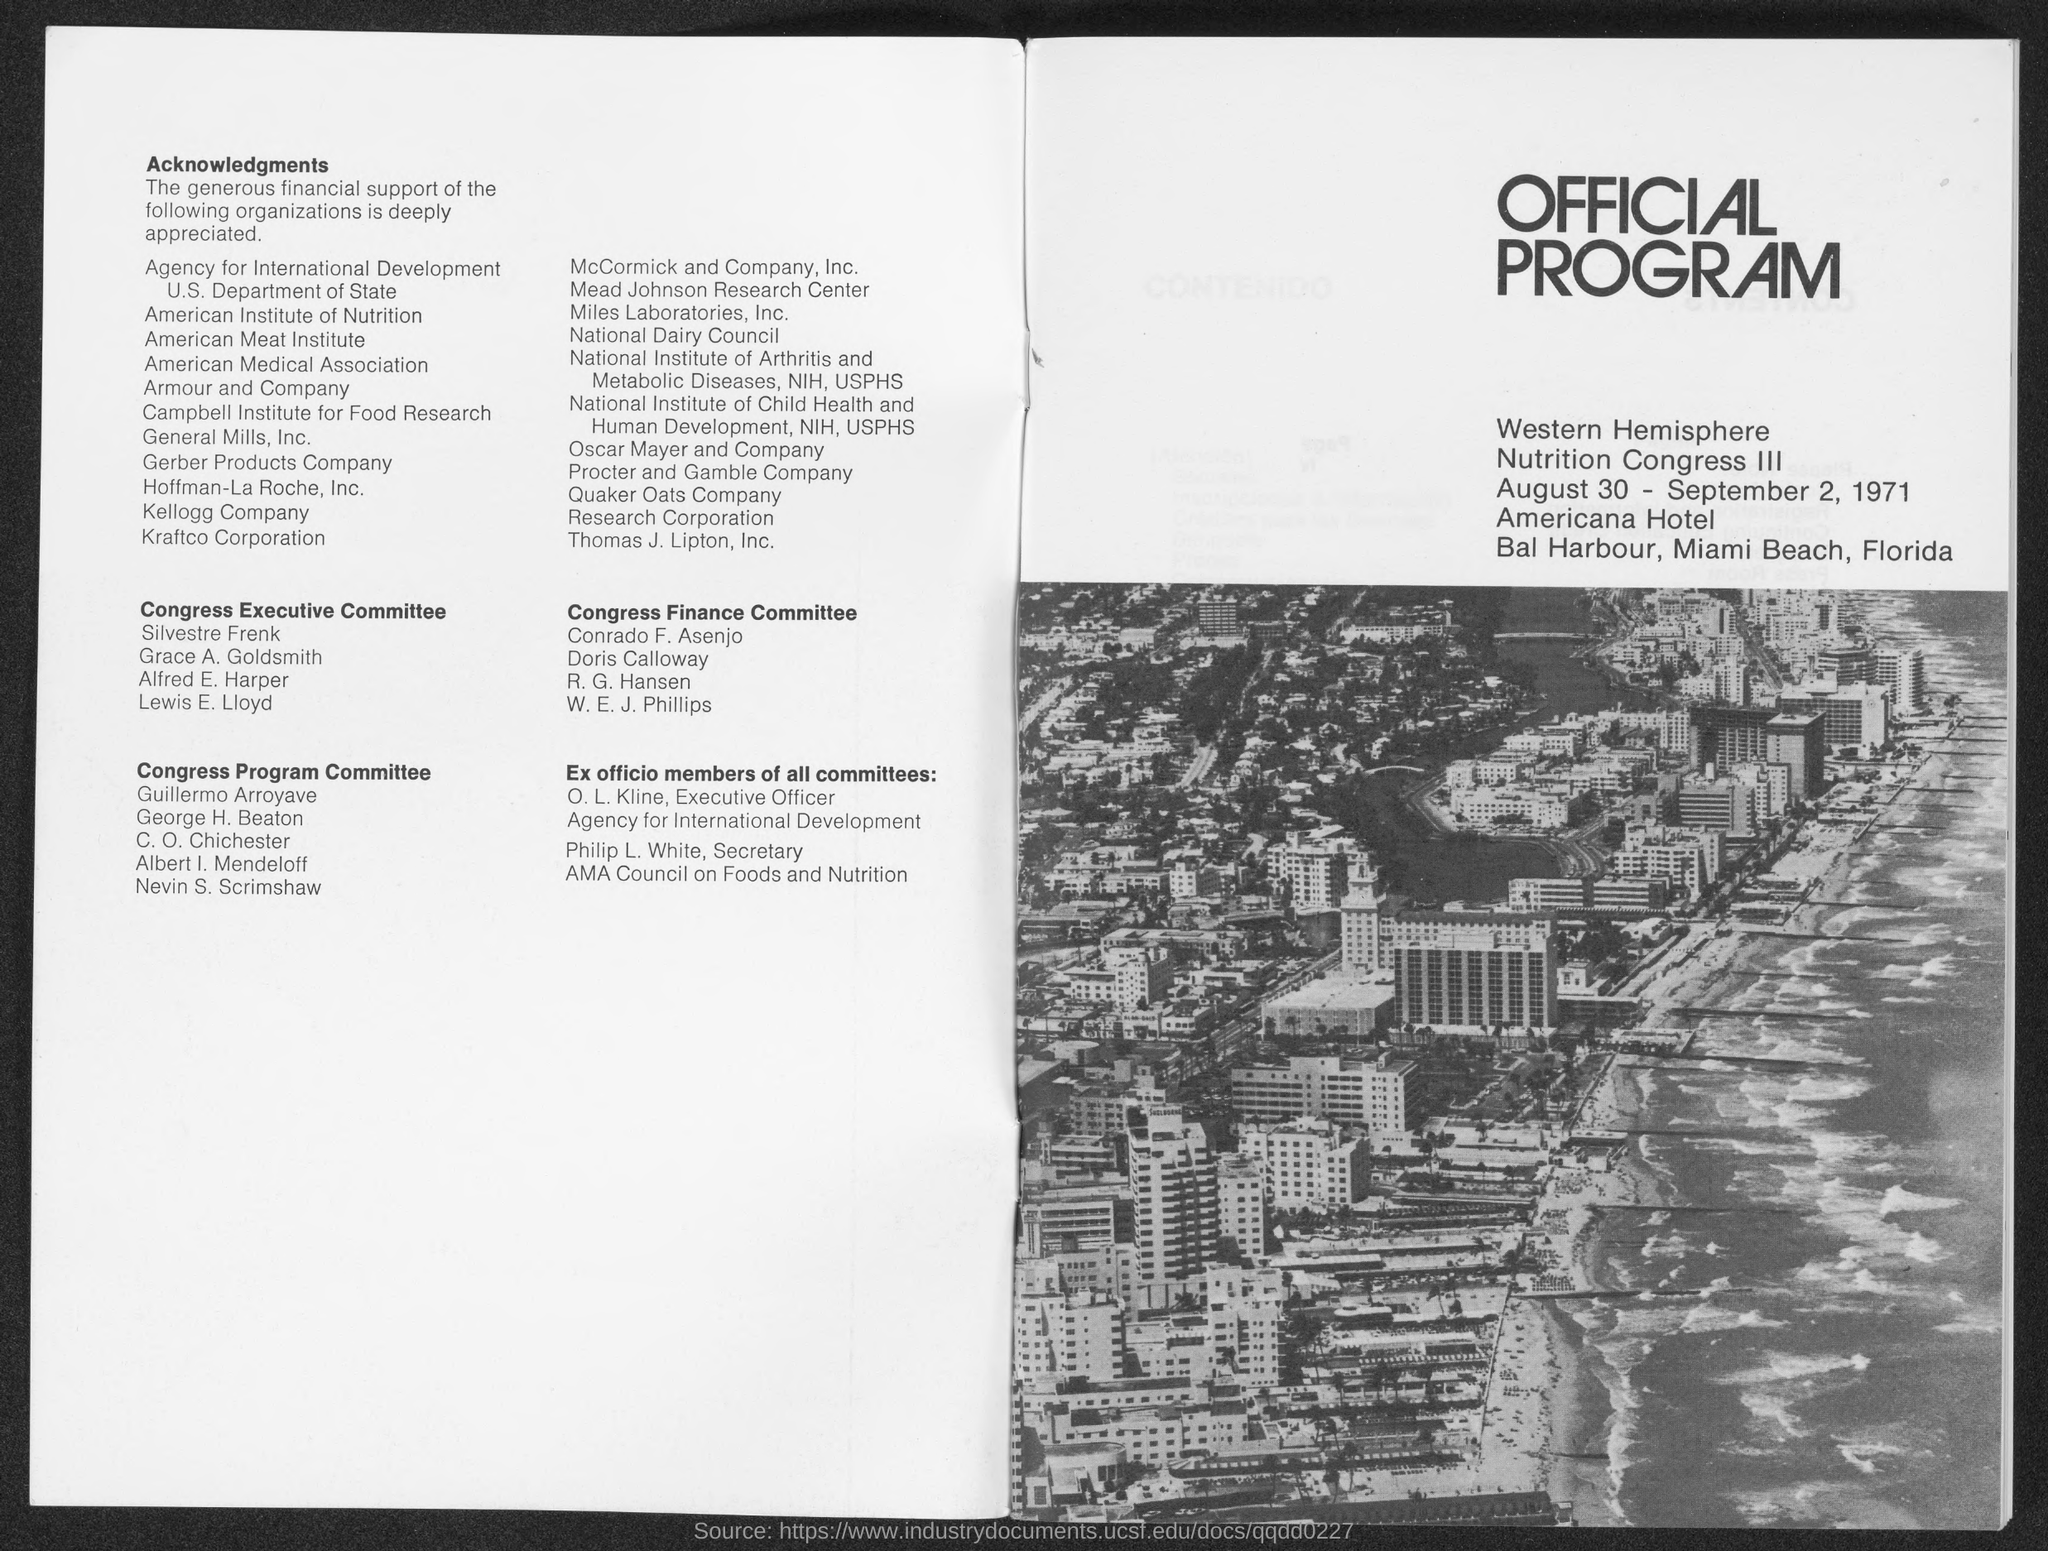List a handful of essential elements in this visual. The official program is scheduled to take place from August 30 to September 2, 1971. The last member of the Congress Executive Committee is Lewis E. Lloyd. William E. J. Phillips is the last member of the Congress Finance Committee. The program will take place on Miami Beach. Conrado F. Asenjo is the first member of the Congress Finance Committee. 